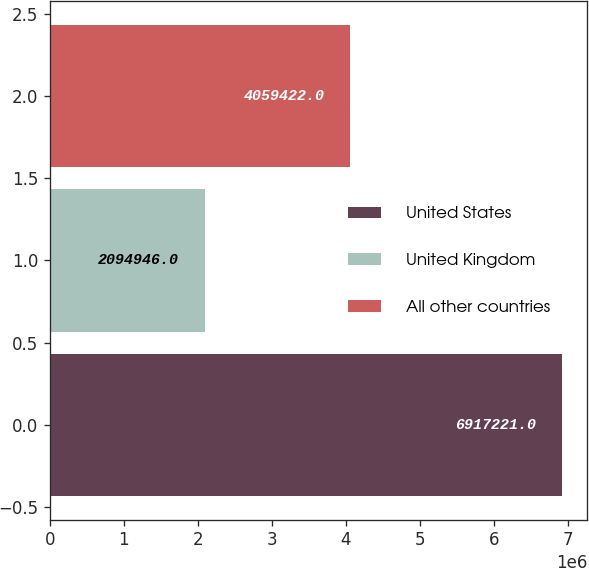<chart> <loc_0><loc_0><loc_500><loc_500><bar_chart><fcel>United States<fcel>United Kingdom<fcel>All other countries<nl><fcel>6.91722e+06<fcel>2.09495e+06<fcel>4.05942e+06<nl></chart> 